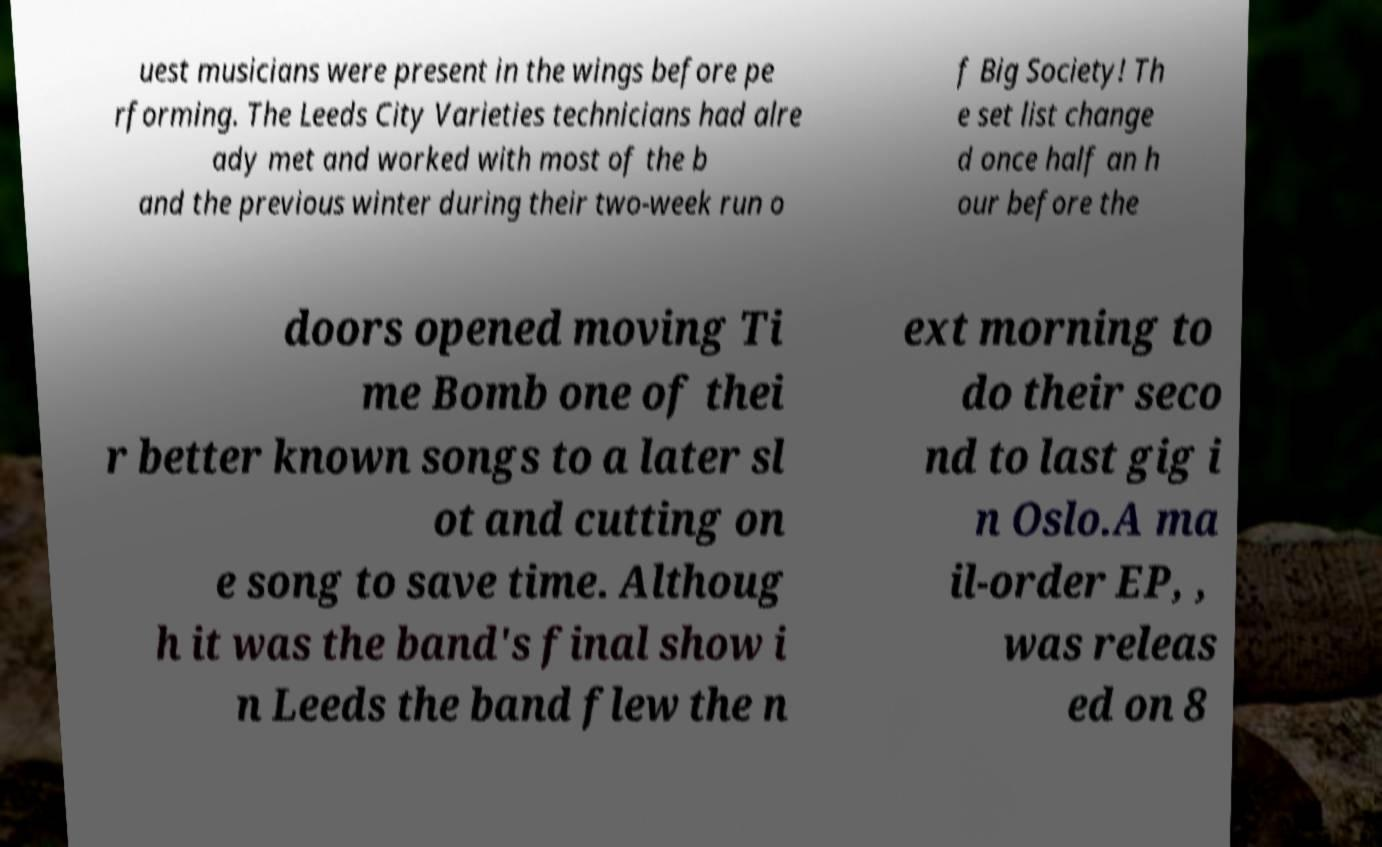For documentation purposes, I need the text within this image transcribed. Could you provide that? uest musicians were present in the wings before pe rforming. The Leeds City Varieties technicians had alre ady met and worked with most of the b and the previous winter during their two-week run o f Big Society! Th e set list change d once half an h our before the doors opened moving Ti me Bomb one of thei r better known songs to a later sl ot and cutting on e song to save time. Althoug h it was the band's final show i n Leeds the band flew the n ext morning to do their seco nd to last gig i n Oslo.A ma il-order EP, , was releas ed on 8 